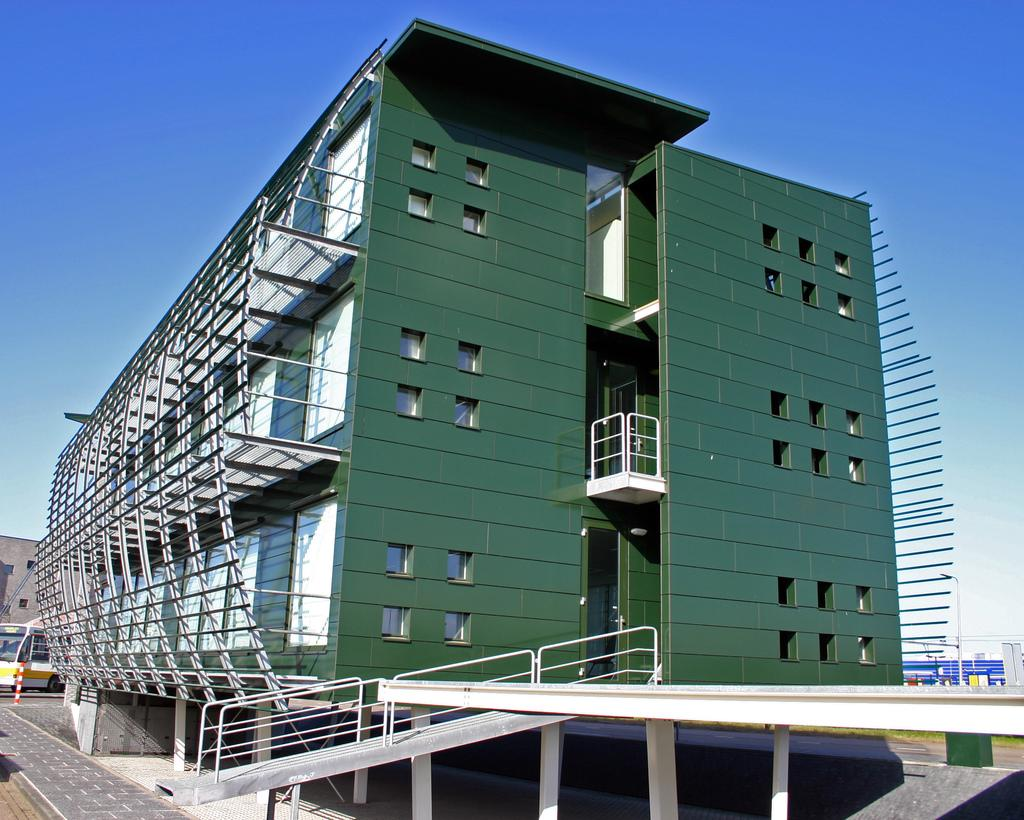What type of structure is present in the image? There is a building in the image. What is the color of the building? The building is green in color. What is located in front of the building? There is a road in front of the building. What can be seen in the background of the image? The sky is visible in the background of the image. Are there any plants growing on the seashore in the image? There is no seashore or plants visible in the image; it features a green building with a road in front of it and a sky in the background. 